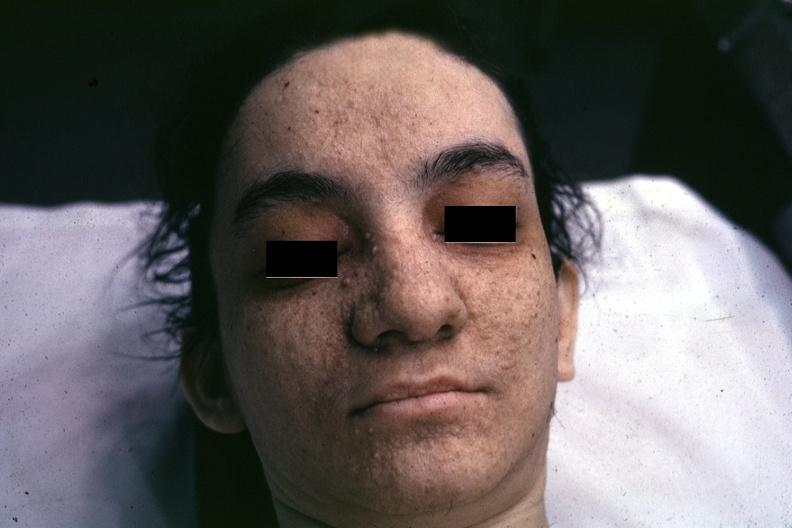s adenoma sebaceum present?
Answer the question using a single word or phrase. Yes 